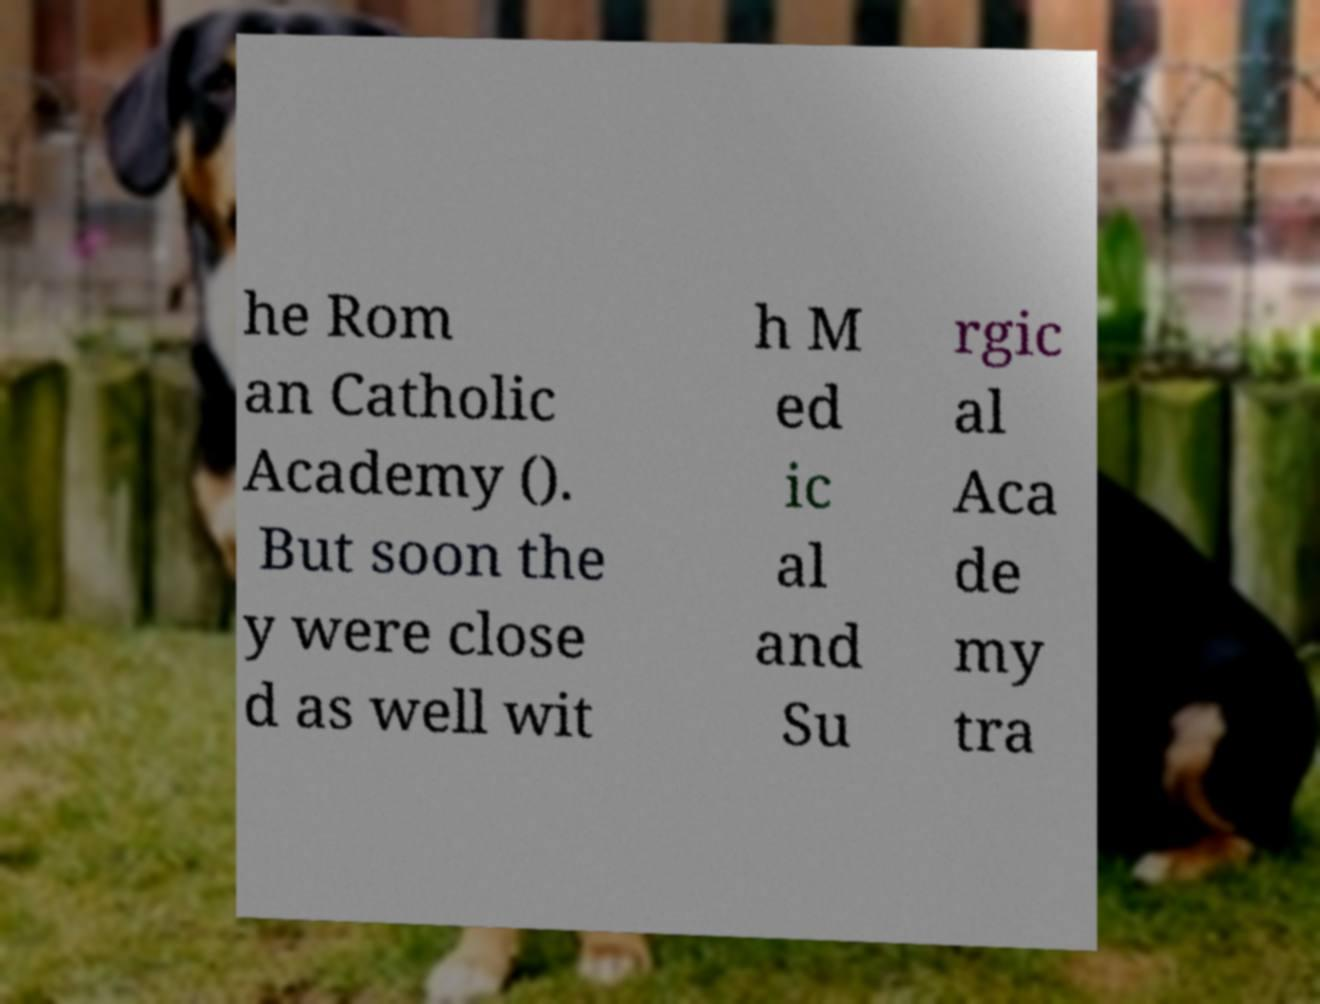Can you read and provide the text displayed in the image?This photo seems to have some interesting text. Can you extract and type it out for me? he Rom an Catholic Academy (). But soon the y were close d as well wit h M ed ic al and Su rgic al Aca de my tra 